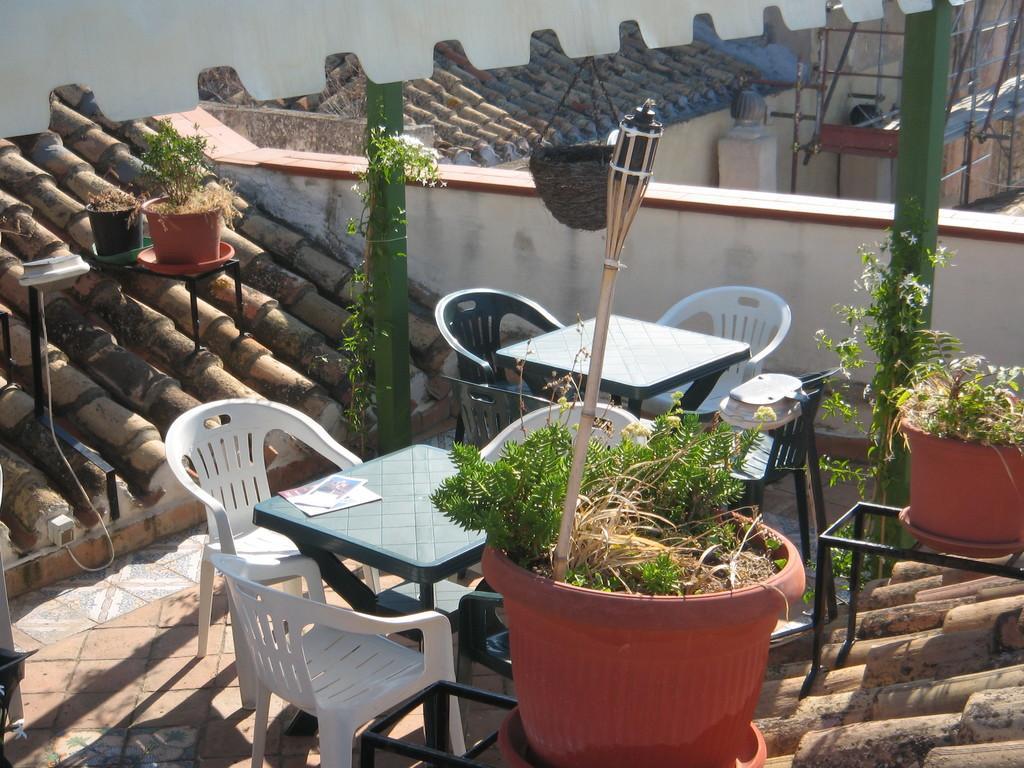In one or two sentences, can you explain what this image depicts? In this picture we can see the roof of the building. On the roof we can see chair, tables, pot, plants, poles and wall. In the top right corner we can see pipe near to the wall. 